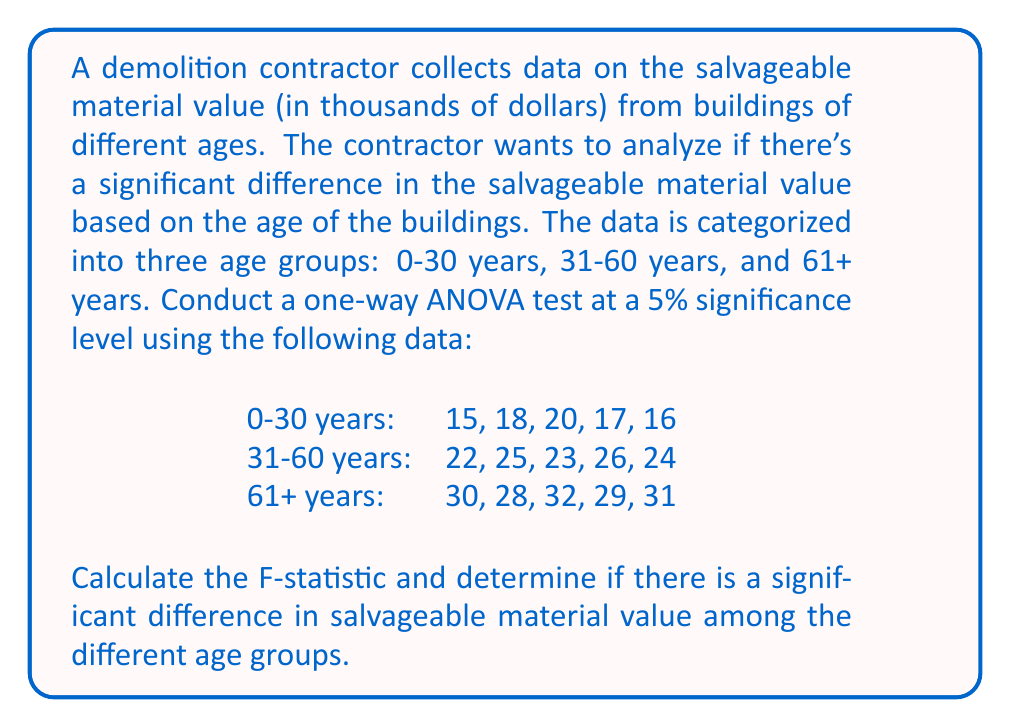Could you help me with this problem? To conduct a one-way ANOVA test, we need to follow these steps:

1. Calculate the sum of squares between groups (SSB), sum of squares within groups (SSW), and total sum of squares (SST).
2. Calculate the degrees of freedom for between groups (dfB), within groups (dfW), and total (dfT).
3. Calculate the mean square between groups (MSB) and mean square within groups (MSW).
4. Calculate the F-statistic.
5. Compare the F-statistic with the critical F-value.

Step 1: Calculate sums of squares

First, we need to calculate the grand mean:
$$\bar{X} = \frac{15 + 18 + 20 + 17 + 16 + 22 + 25 + 23 + 26 + 24 + 30 + 28 + 32 + 29 + 31}{15} = 23.73$$

Now, let's calculate the group means:
$$\bar{X}_1 = \frac{15 + 18 + 20 + 17 + 16}{5} = 17.2$$
$$\bar{X}_2 = \frac{22 + 25 + 23 + 26 + 24}{5} = 24$$
$$\bar{X}_3 = \frac{30 + 28 + 32 + 29 + 31}{5} = 30$$

SSB = $\sum_{i=1}^{k} n_i(\bar{X}_i - \bar{X})^2$
    = $5(17.2 - 23.73)^2 + 5(24 - 23.73)^2 + 5(30 - 23.73)^2$
    = $5((-6.53)^2 + 0.27^2 + 6.27^2)$
    = $5(42.64 + 0.07 + 39.31)$
    = $410.1$

SSW = $\sum_{i=1}^{k} \sum_{j=1}^{n_i} (X_{ij} - \bar{X}_i)^2$
    = $((15-17.2)^2 + (18-17.2)^2 + (20-17.2)^2 + (17-17.2)^2 + (16-17.2)^2)$
    + $((22-24)^2 + (25-24)^2 + (23-24)^2 + (26-24)^2 + (24-24)^2)$
    + $((30-30)^2 + (28-30)^2 + (32-30)^2 + (29-30)^2 + (31-30)^2)$
    = $(4.84 + 0.64 + 7.84 + 0.04 + 1.44) + (4 + 1 + 1 + 4 + 0) + (0 + 4 + 4 + 1 + 1)$
    = $34.8$

SST = SSB + SSW = 410.1 + 34.8 = 444.9

Step 2: Calculate degrees of freedom

dfB = k - 1 = 3 - 1 = 2 (k is the number of groups)
dfW = N - k = 15 - 3 = 12 (N is the total number of observations)
dfT = N - 1 = 15 - 1 = 14

Step 3: Calculate mean squares

MSB = SSB / dfB = 410.1 / 2 = 205.05
MSW = SSW / dfW = 34.8 / 12 = 2.9

Step 4: Calculate F-statistic

$$F = \frac{MSB}{MSW} = \frac{205.05}{2.9} = 70.71$$

Step 5: Compare F-statistic with critical F-value

At a 5% significance level with dfB = 2 and dfW = 12, the critical F-value is approximately 3.89 (from F-distribution table).

Since the calculated F-statistic (70.71) is greater than the critical F-value (3.89), we reject the null hypothesis.
Answer: The calculated F-statistic is 70.71. Since this value is greater than the critical F-value of 3.89 at a 5% significance level, we conclude that there is a significant difference in salvageable material value among the different age groups of buildings. 